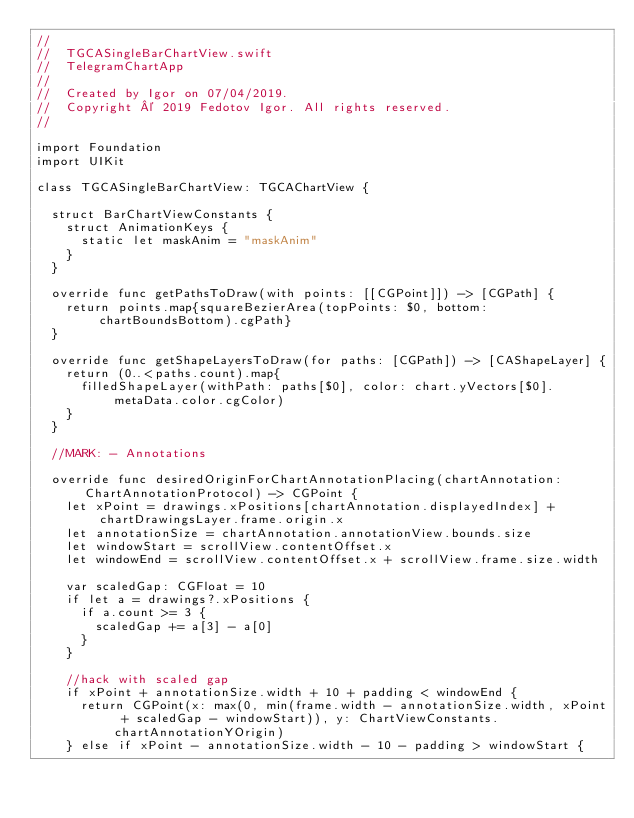Convert code to text. <code><loc_0><loc_0><loc_500><loc_500><_Swift_>//
//  TGCASingleBarChartView.swift
//  TelegramChartApp
//
//  Created by Igor on 07/04/2019.
//  Copyright © 2019 Fedotov Igor. All rights reserved.
//

import Foundation
import UIKit

class TGCASingleBarChartView: TGCAChartView {
  
  struct BarChartViewConstants {
    struct AnimationKeys {
      static let maskAnim = "maskAnim"
    }
  }
  
  override func getPathsToDraw(with points: [[CGPoint]]) -> [CGPath] {
    return points.map{squareBezierArea(topPoints: $0, bottom: chartBoundsBottom).cgPath}
  }
  
  override func getShapeLayersToDraw(for paths: [CGPath]) -> [CAShapeLayer] {
    return (0..<paths.count).map{
      filledShapeLayer(withPath: paths[$0], color: chart.yVectors[$0].metaData.color.cgColor)
    }
  }
  
  //MARK: - Annotations
  
  override func desiredOriginForChartAnnotationPlacing(chartAnnotation: ChartAnnotationProtocol) -> CGPoint {
    let xPoint = drawings.xPositions[chartAnnotation.displayedIndex] + chartDrawingsLayer.frame.origin.x
    let annotationSize = chartAnnotation.annotationView.bounds.size
    let windowStart = scrollView.contentOffset.x
    let windowEnd = scrollView.contentOffset.x + scrollView.frame.size.width
    
    var scaledGap: CGFloat = 10
    if let a = drawings?.xPositions {
      if a.count >= 3 {
        scaledGap += a[3] - a[0]
      }
    }
    
    //hack with scaled gap
    if xPoint + annotationSize.width + 10 + padding < windowEnd {
      return CGPoint(x: max(0, min(frame.width - annotationSize.width, xPoint + scaledGap - windowStart)), y: ChartViewConstants.chartAnnotationYOrigin)
    } else if xPoint - annotationSize.width - 10 - padding > windowStart {</code> 